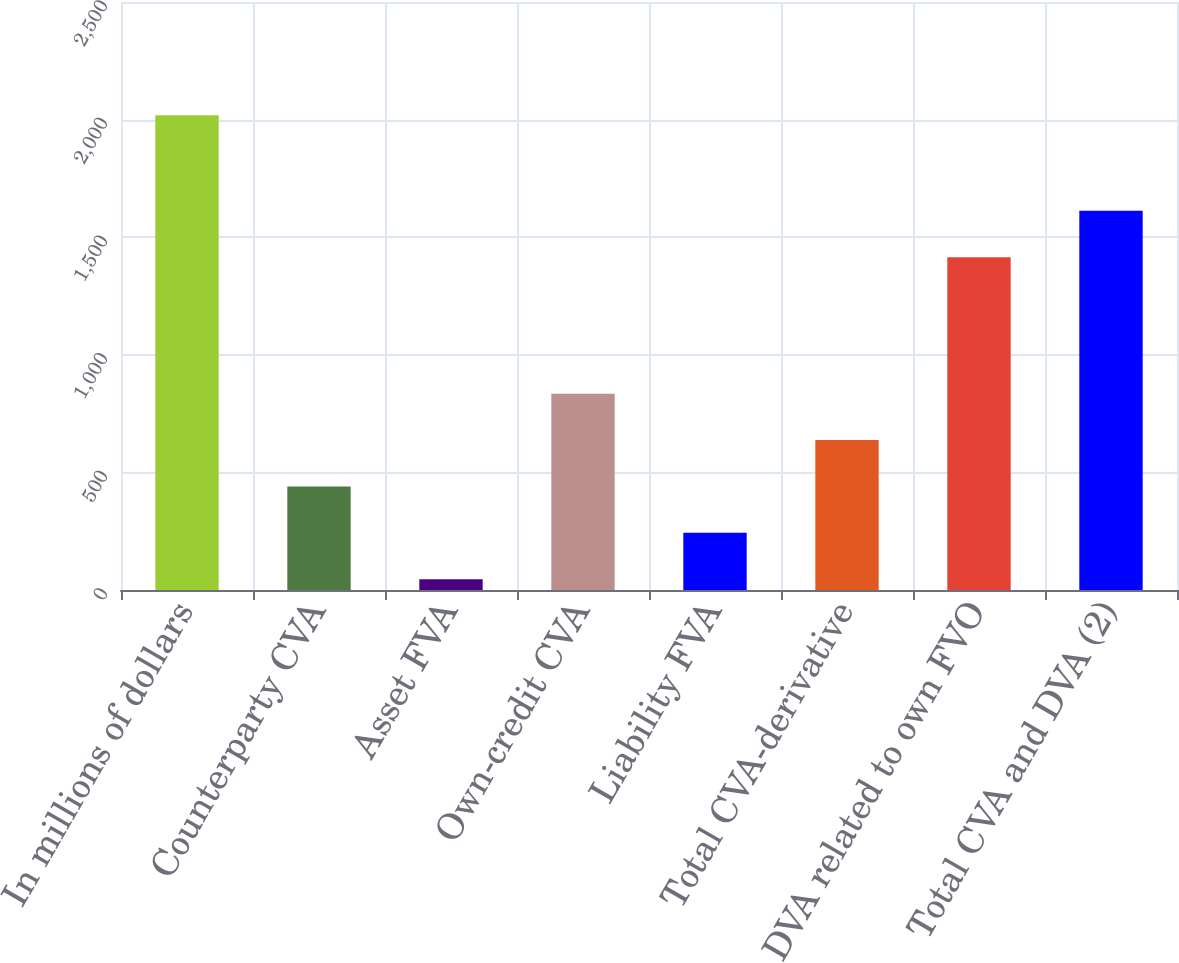<chart> <loc_0><loc_0><loc_500><loc_500><bar_chart><fcel>In millions of dollars<fcel>Counterparty CVA<fcel>Asset FVA<fcel>Own-credit CVA<fcel>Liability FVA<fcel>Total CVA-derivative<fcel>DVA related to own FVO<fcel>Total CVA and DVA (2)<nl><fcel>2018<fcel>440.4<fcel>46<fcel>834.8<fcel>243.2<fcel>637.6<fcel>1415<fcel>1612.2<nl></chart> 